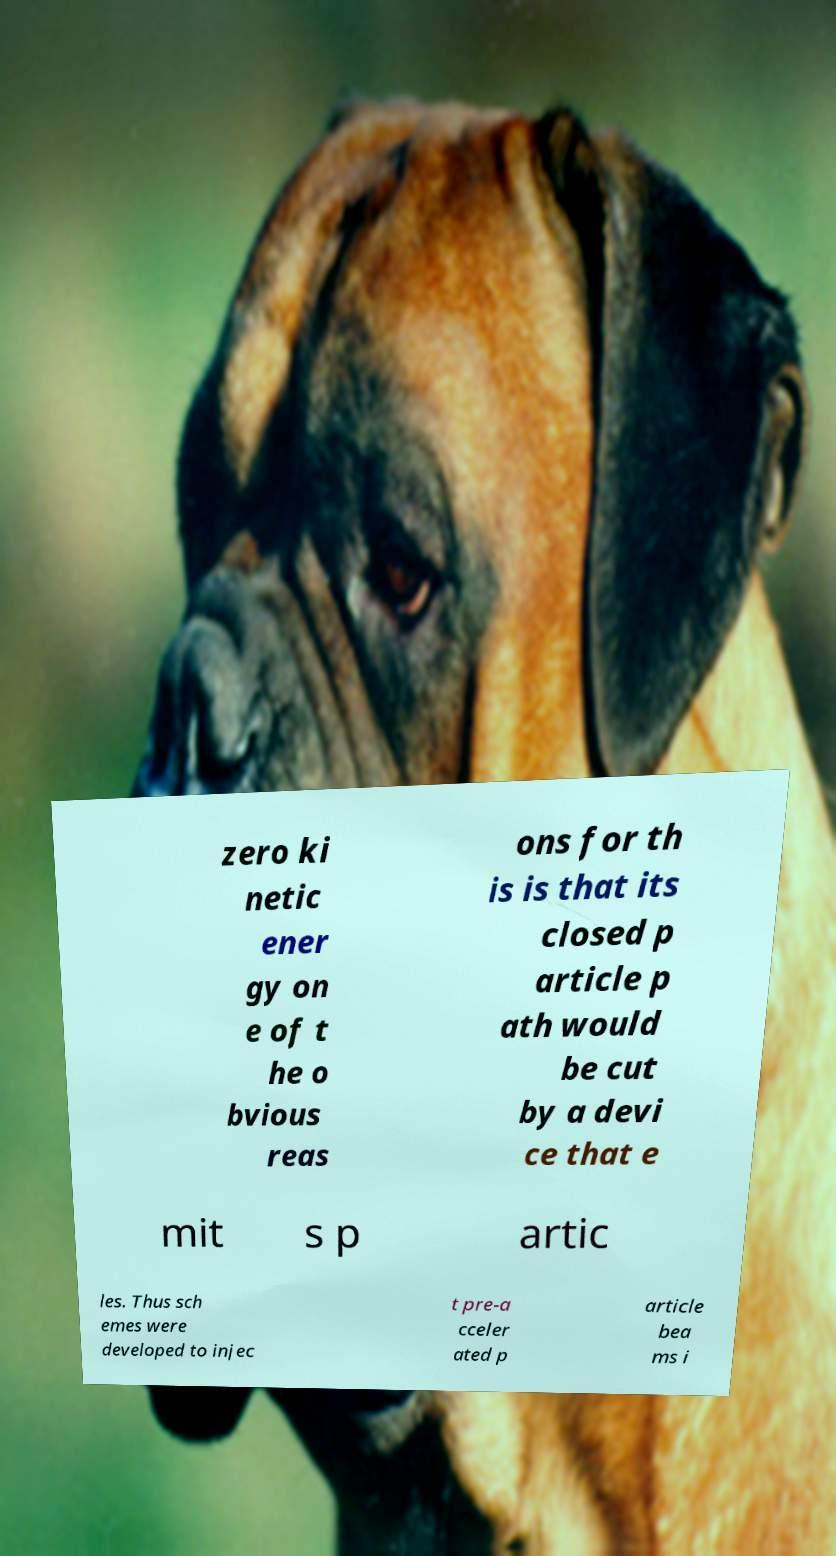For documentation purposes, I need the text within this image transcribed. Could you provide that? zero ki netic ener gy on e of t he o bvious reas ons for th is is that its closed p article p ath would be cut by a devi ce that e mit s p artic les. Thus sch emes were developed to injec t pre-a cceler ated p article bea ms i 